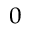<formula> <loc_0><loc_0><loc_500><loc_500>^ { 0 }</formula> 